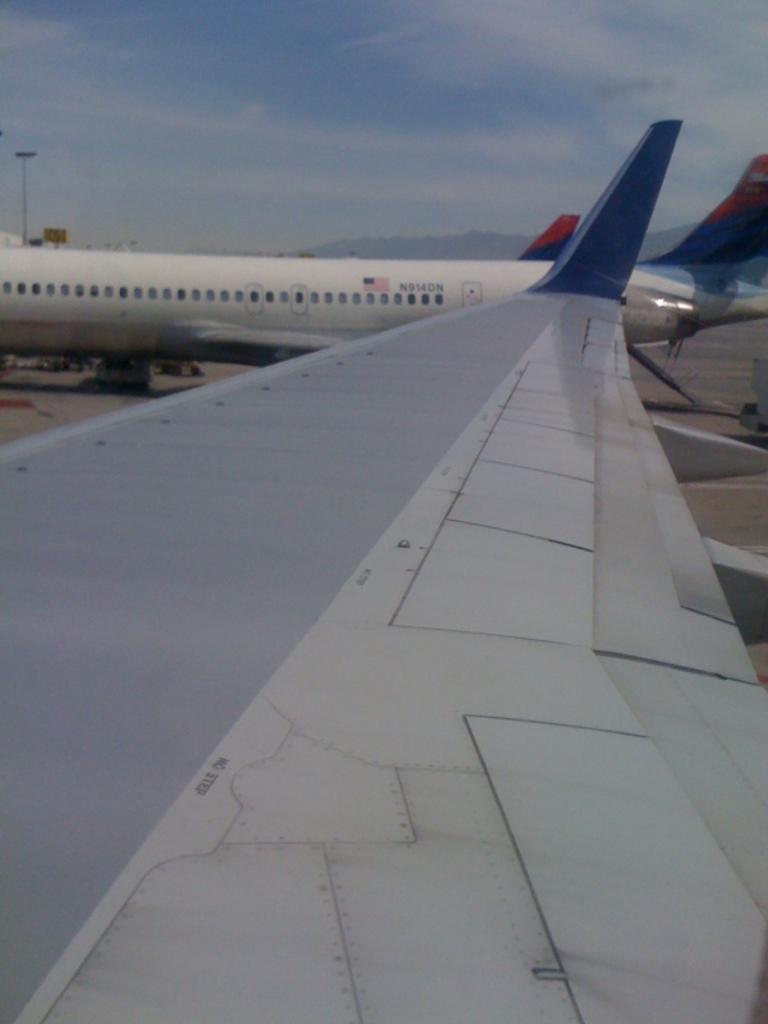Can you describe this image briefly? In the image there are aeroplanes on the road and above its sky with clouds. 